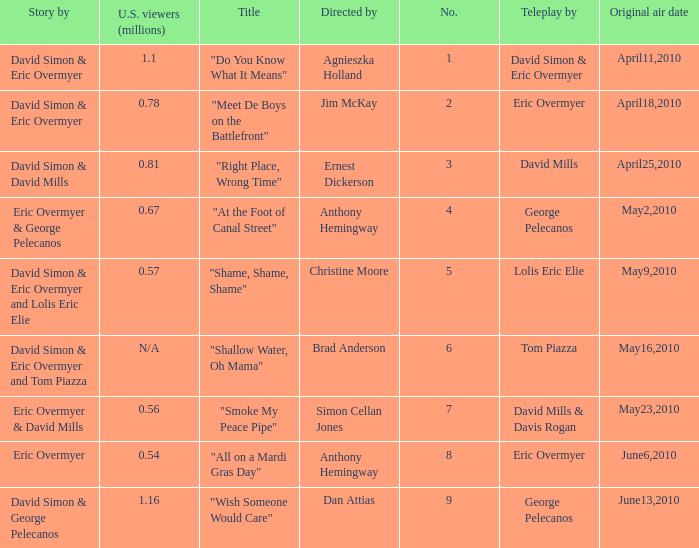Name the most number 9.0. 